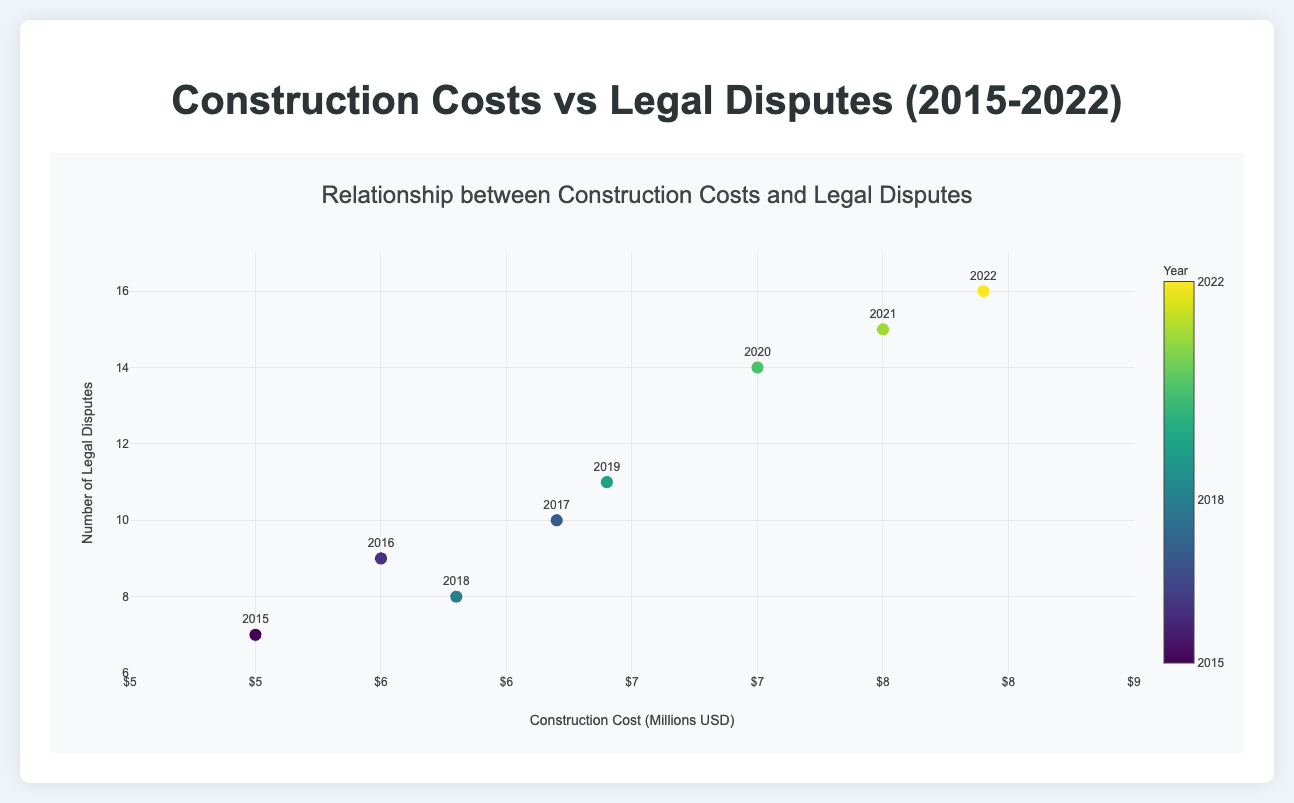What's the title of the plot? The title is displayed at the top of the plot and serves as the heading. It is "Relationship between Construction Costs and Legal Disputes."
Answer: Relationship between Construction Costs and Legal Disputes What does the x-axis represent in the plot? The x-axis is labeled and indicates what is being measured along it. It represents the "Construction Cost (Millions USD)."
Answer: Construction Cost (Millions USD) How many legal disputes were there in 2017? Locate the year 2017 on the plot, and look at the y-value corresponding to this year. The y-value shows the number of legal disputes for 2017, which is 10.
Answer: 10 What is the range of construction costs shown on the x-axis? The x-axis shows the range of construction costs, which can be determined by looking at the minimum and maximum values along this axis. The range is from $4.5 million to $8.5 million.
Answer: $4.5 million to $8.5 million How does the number of legal disputes in 2020 compare to 2019? Check the y-values for the years 2020 and 2019 on the scatter plot. In 2020, there are 14 legal disputes, while in 2019 there are 11. Thus, 2020 has 3 more disputes than 2019.
Answer: 3 more disputes in 2020 What is the trend in the number of legal disputes over time? By observing the general direction and pattern of the points as they progress through the years, it shows that the number of legal disputes tends to increase over time.
Answer: Increasing trend Identify the year with the highest construction cost and indicate how many legal disputes occurred that year. Locate the point with the highest x-value (construction cost). The highest construction cost is in 2022 at $7.9 million. The corresponding y-value shows 16 legal disputes.
Answer: 2022, 16 legal disputes What is the average construction cost over the years 2015-2022? Sum all the construction costs from each year and then divide by the number of years: (5000000 + 5500000 + 6200000 + 5800000 + 6400000 + 7000000 + 7500000 + 7900000) / 8 = $6,412,500
Answer: $6,412,500 Which year had more legal disputes, 2018 or 2016? Find the y-values for both 2018 and 2016 on the plot. 2018 had 8 legal disputes, and 2016 had 9. Therefore, 2016 had more legal disputes.
Answer: 2016 What is the correlation between construction costs and legal disputes? Correlation indicates the relationship between two variables. As construction costs increase, the number of legal disputes also tends to increase, suggesting a positive correlation.
Answer: Positive correlation 